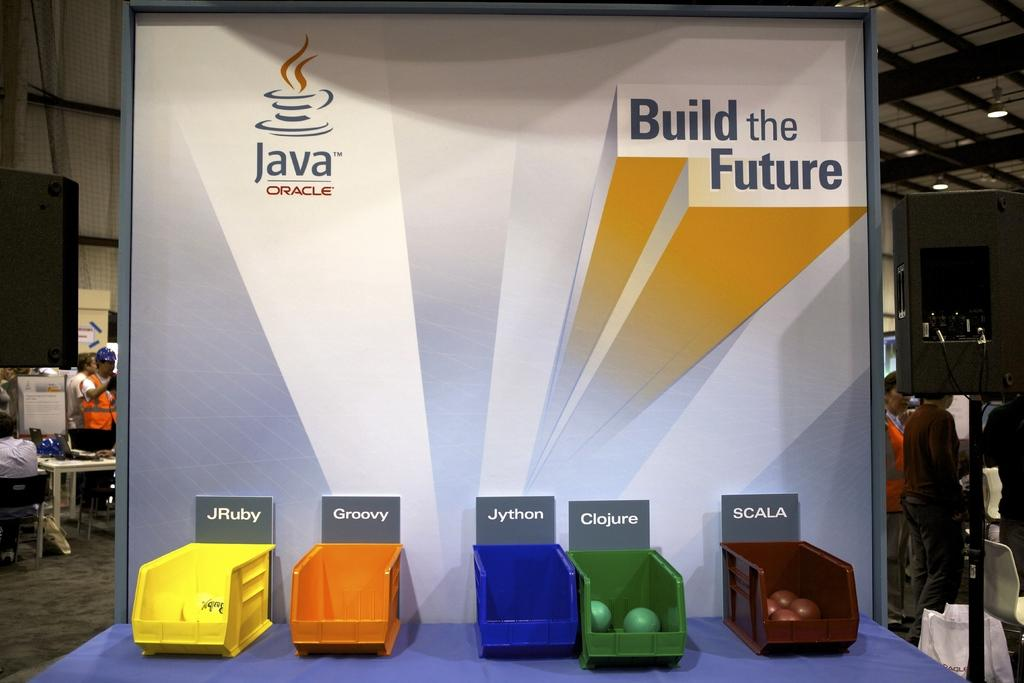Provide a one-sentence caption for the provided image. A group of colored containers with the groovy written above the orange one. 